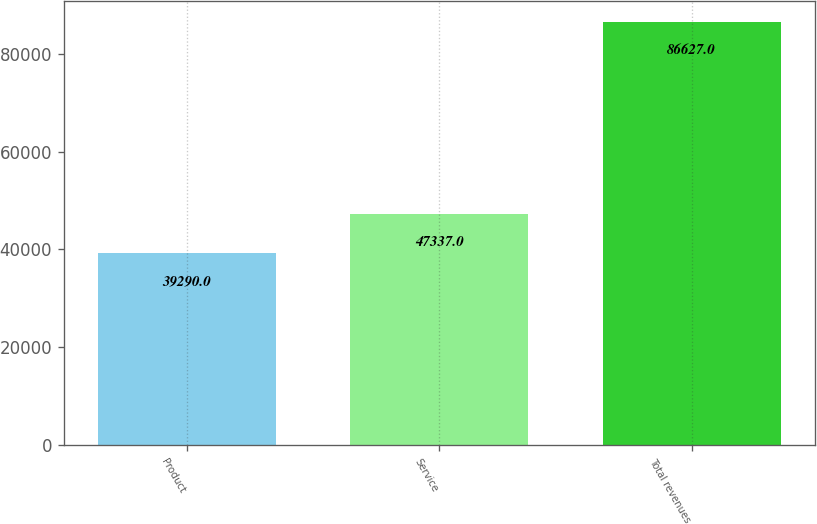<chart> <loc_0><loc_0><loc_500><loc_500><bar_chart><fcel>Product<fcel>Service<fcel>Total revenues<nl><fcel>39290<fcel>47337<fcel>86627<nl></chart> 